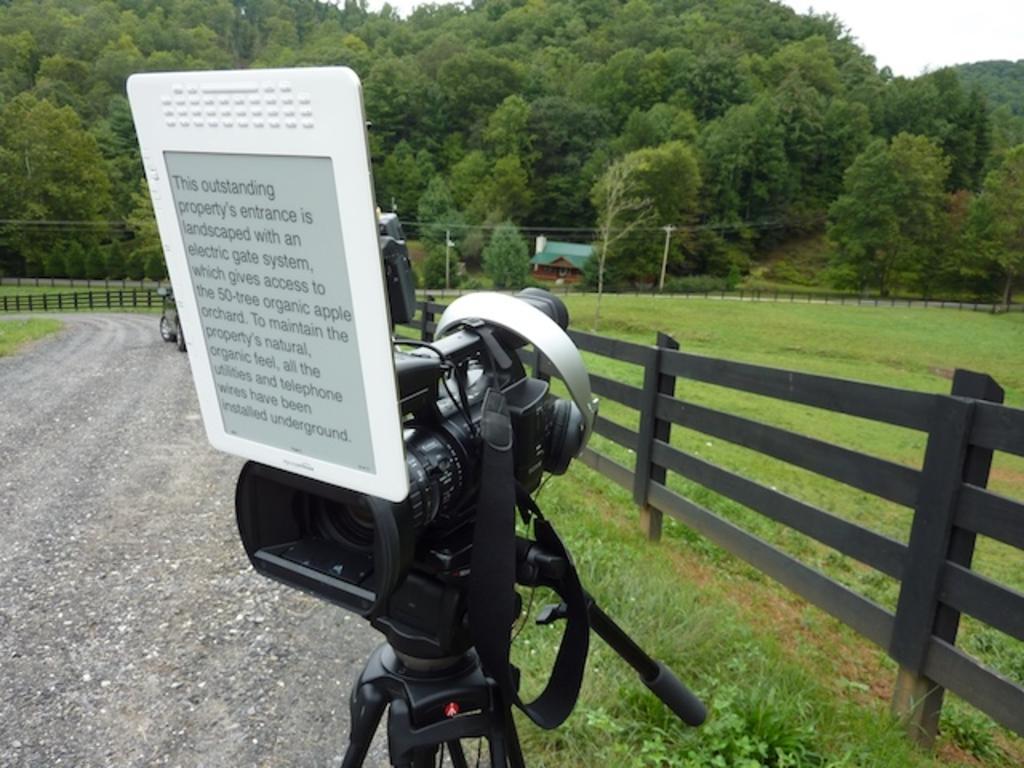Please provide a concise description of this image. In this picture I can see video camera on camera stand, trees, a fence and poles on which wires are attached. In the background I can see a house. On the left side I can see a road and grass. 